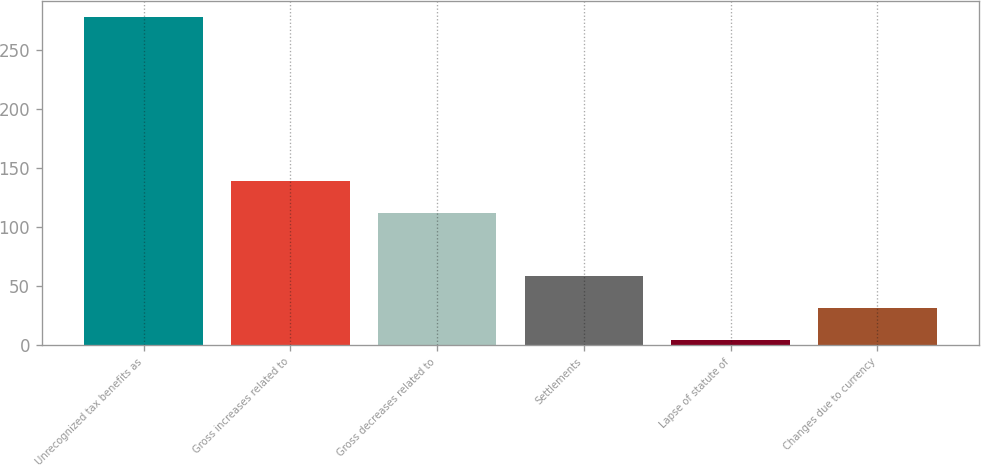Convert chart. <chart><loc_0><loc_0><loc_500><loc_500><bar_chart><fcel>Unrecognized tax benefits as<fcel>Gross increases related to<fcel>Gross decreases related to<fcel>Settlements<fcel>Lapse of statute of<fcel>Changes due to currency<nl><fcel>278.08<fcel>139<fcel>112.02<fcel>58.06<fcel>4.1<fcel>31.08<nl></chart> 